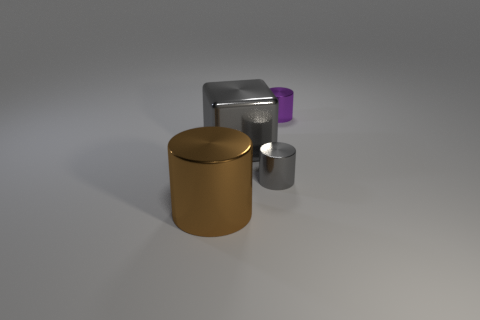There is a brown object that is the same shape as the purple shiny object; what material is it?
Give a very brief answer. Metal. What number of tiny things are gray cylinders or purple metal cylinders?
Provide a short and direct response. 2. Is the number of gray objects that are right of the small purple thing less than the number of big metal cylinders that are in front of the big brown metallic thing?
Keep it short and to the point. No. How many objects are either large brown things or small cylinders?
Your answer should be compact. 3. What number of tiny purple cylinders are right of the large brown cylinder?
Keep it short and to the point. 1. There is a small purple object that is the same material as the big cube; what shape is it?
Your response must be concise. Cylinder. Is the shape of the large object that is right of the big brown thing the same as  the tiny purple thing?
Give a very brief answer. No. How many purple things are either small cylinders or metal cylinders?
Offer a terse response. 1. Are there an equal number of gray cylinders that are in front of the brown metal cylinder and large brown cylinders on the right side of the tiny purple shiny cylinder?
Your answer should be compact. Yes. What color is the small metallic cylinder that is in front of the tiny thing behind the gray metallic object that is on the right side of the gray block?
Provide a short and direct response. Gray. 